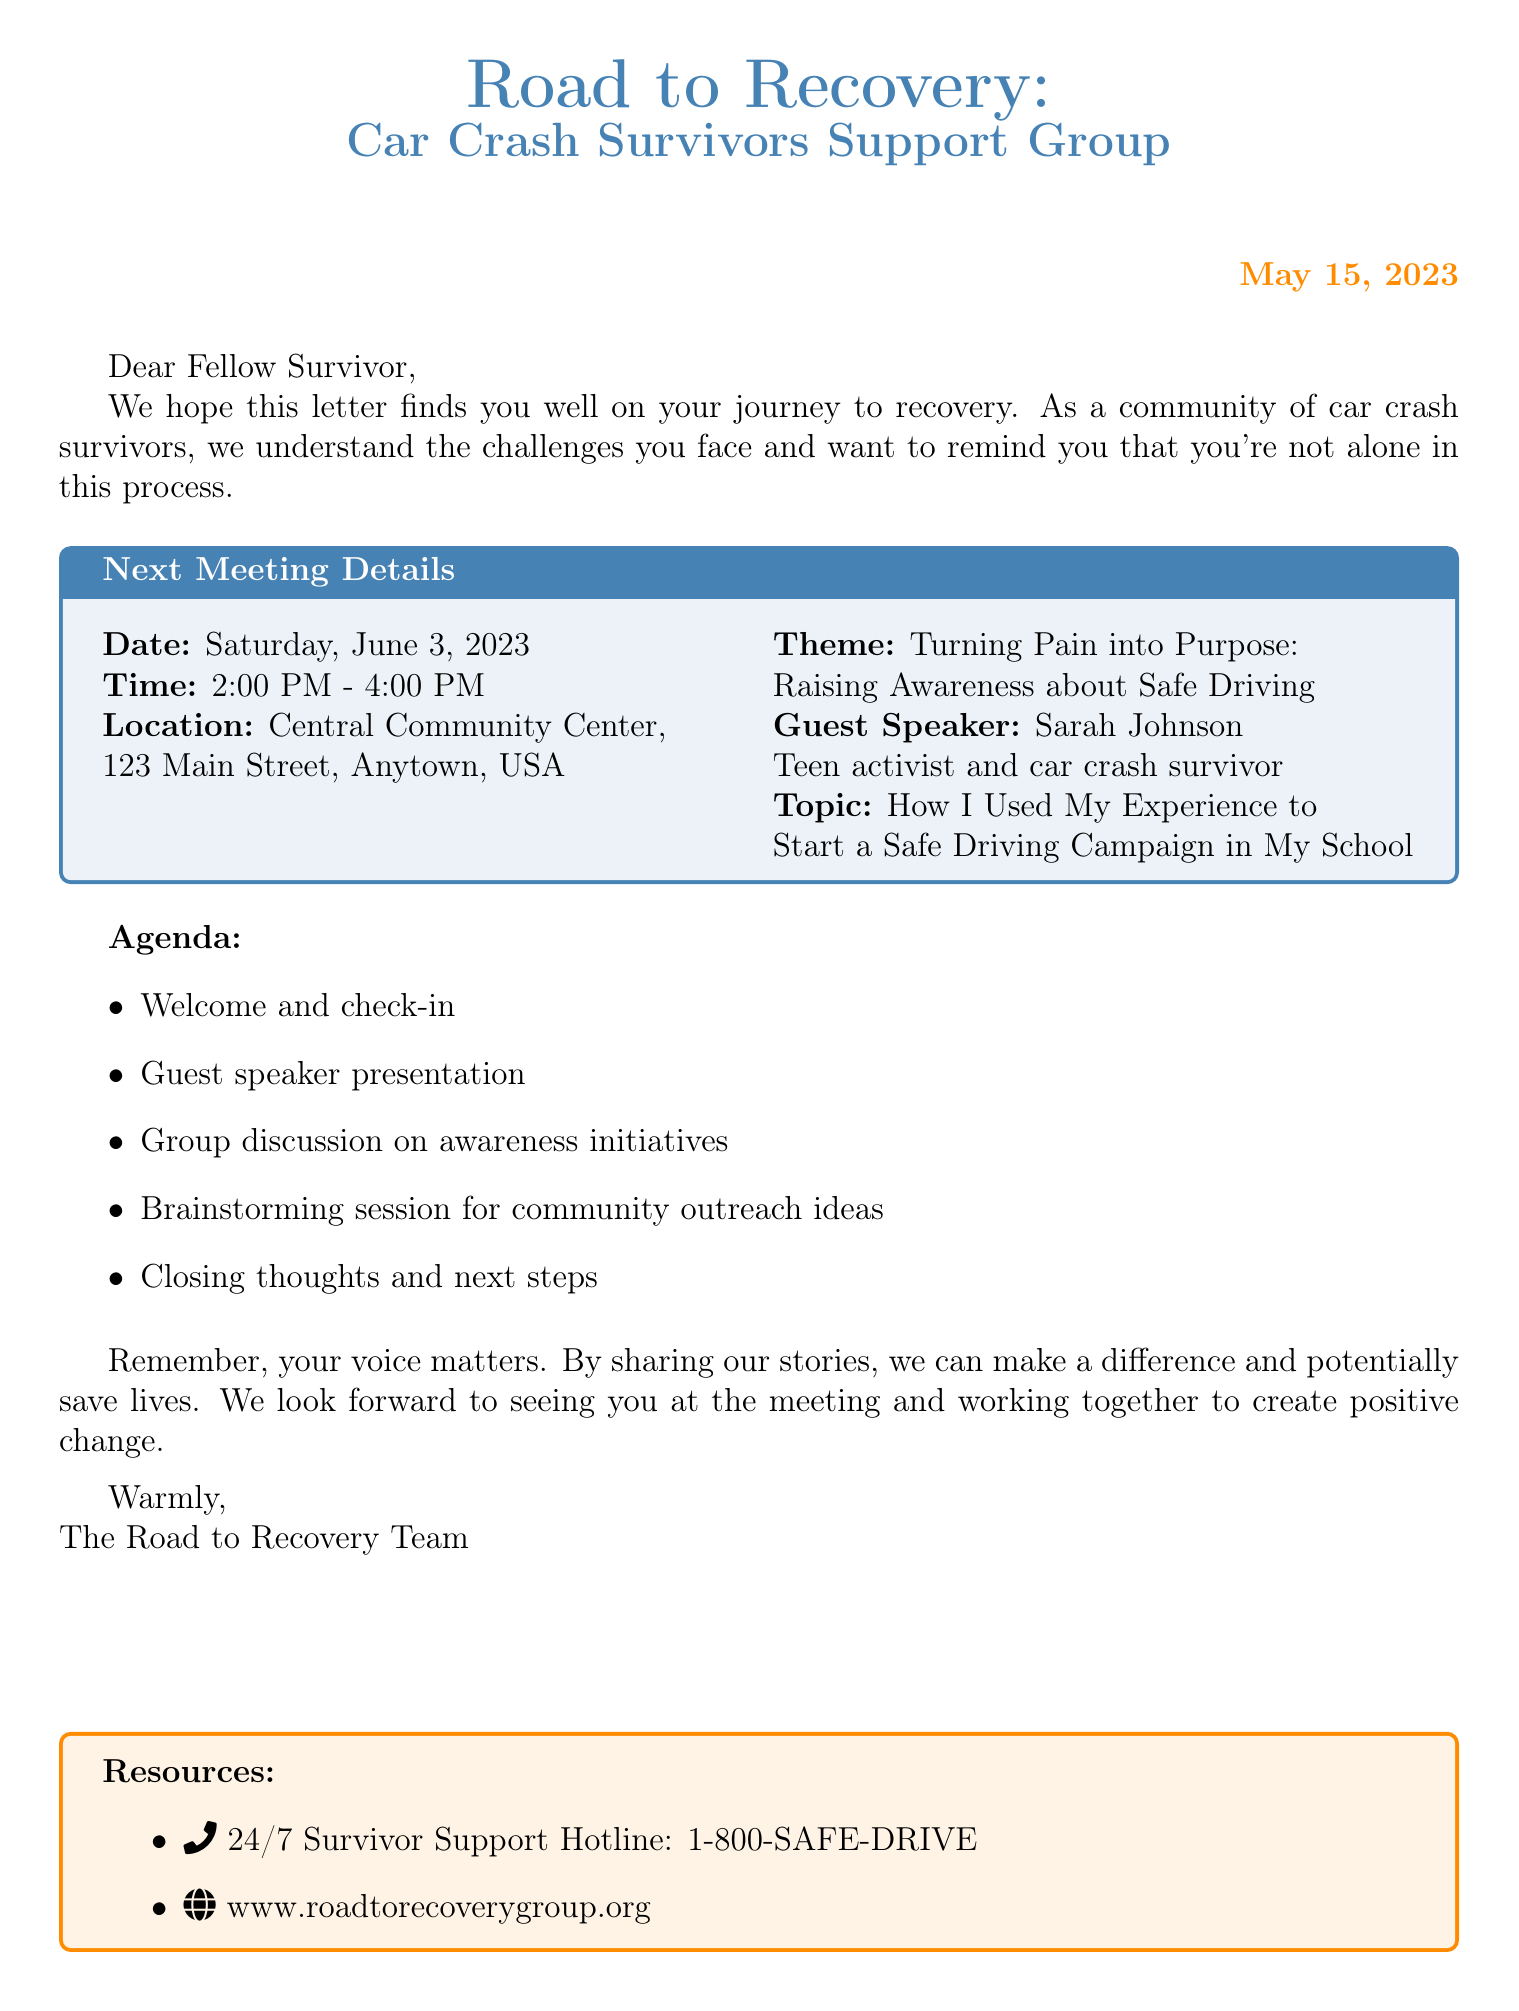What is the name of the support group? The document states the name of the support group at the very top.
Answer: Road to Recovery: Car Crash Survivors Support Group When is the next meeting scheduled? The document specifies the date of the upcoming meeting in the meeting details section.
Answer: Saturday, June 3, 2023 What is the theme of the next meeting? The theme is indicated in the meeting details and emphasizes the purpose of the gathering.
Answer: Turning Pain into Purpose: Raising Awareness about Safe Driving Who is the guest speaker at the meeting? The document names the guest speaker in the meeting details section.
Answer: Sarah Johnson What time does the meeting begin? The start time is provided in the meeting details.
Answer: 2:00 PM What is one of the agenda items for the meeting? The agenda includes several items listed in the document.
Answer: Guest speaker presentation What resources are provided in the document? The document lists available resources at the end, including a hotline and website.
Answer: 24/7 Survivor Support Hotline: 1-800-SAFE-DRIVE What is the purpose of sharing our stories according to the letter? The document expresses the intention behind sharing stories towards the end.
Answer: Make a difference and potentially save lives 